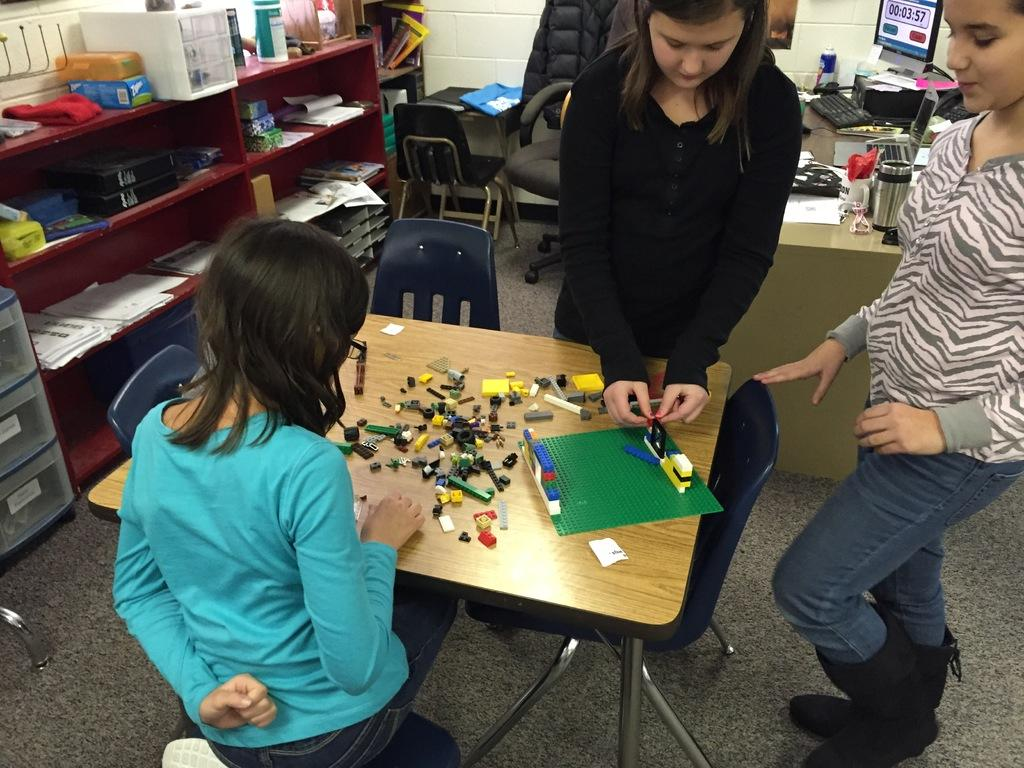How many girls are in the image? There are three girls in the image. What are the girls doing in the image? The girls are standing. What can be seen in the image besides the girls? There is a table, items on the table, a shelf, and items on the shelf in the image. What type of prose is being recited by the creature in the image? There is no creature present in the image, and therefore no prose being recited. What songs are the girls singing in the image? The provided facts do not mention any singing or songs in the image. 